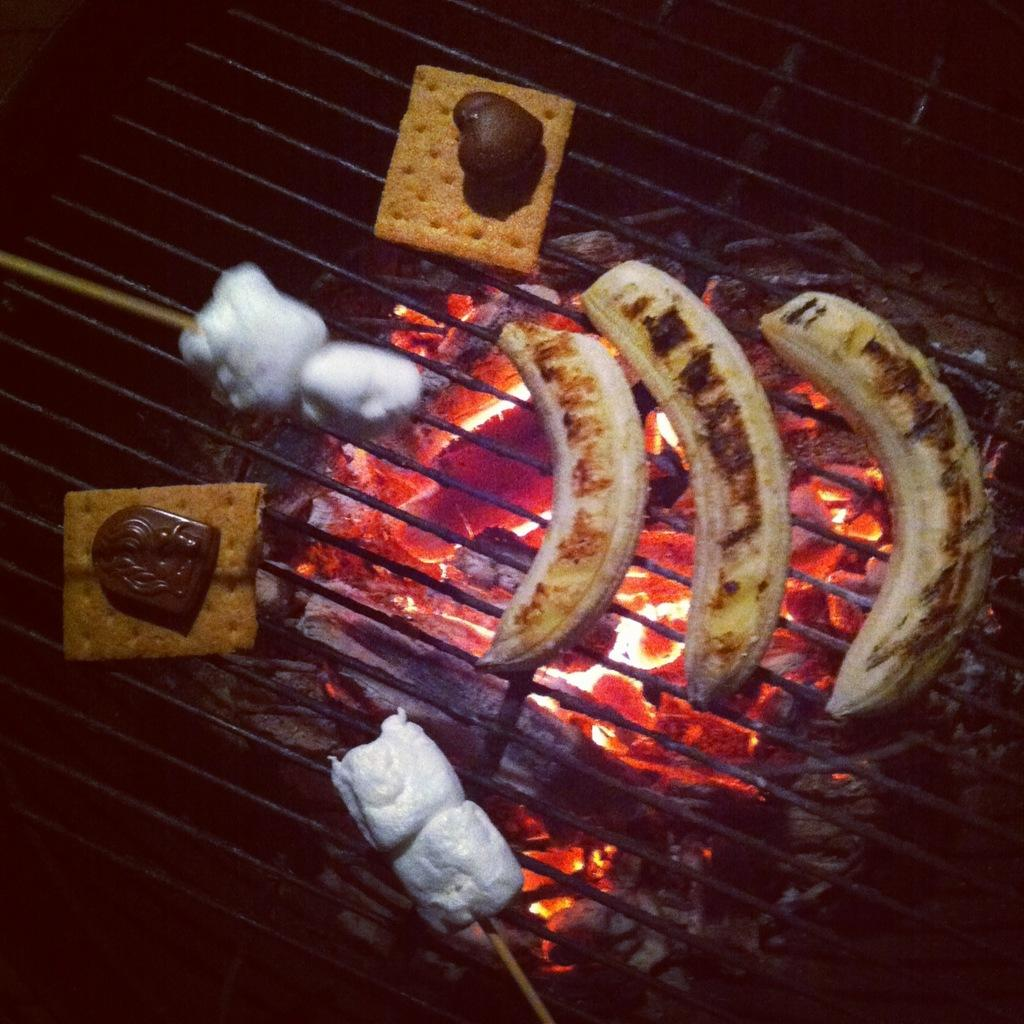What is being cooked in the image? There are food items on a grill in the image. Who is present in the image? There is a girl standing near a fire in the image. What type of industry is depicted in the image? There is no industry depicted in the image; it features a girl standing near a fire with food items on a grill. Can you see a ring on the girl's finger in the image? There is no mention of a ring or any jewelry in the image, so it cannot be determined if the girl is wearing one. 